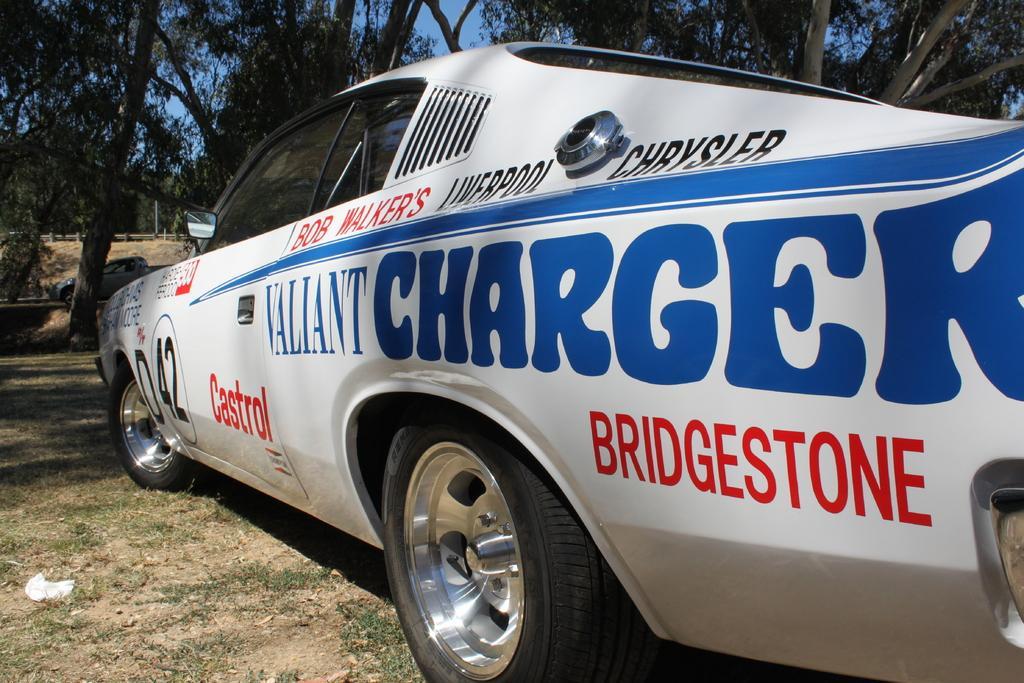In one or two sentences, can you explain what this image depicts? In this image we can see a car with a text. In the background there are trees. Also there is sky. On the ground there is grass. Also we can see a vehicle in the background. 